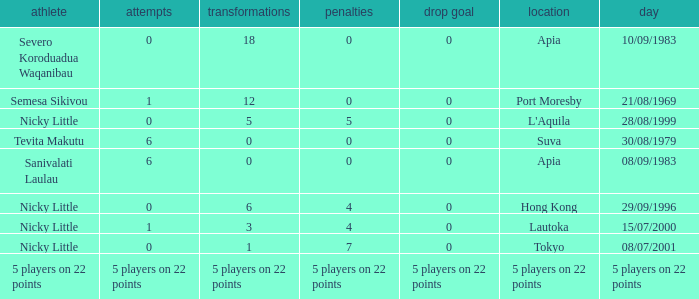How many conversions did Severo Koroduadua Waqanibau have when he has 0 pens? 18.0. 